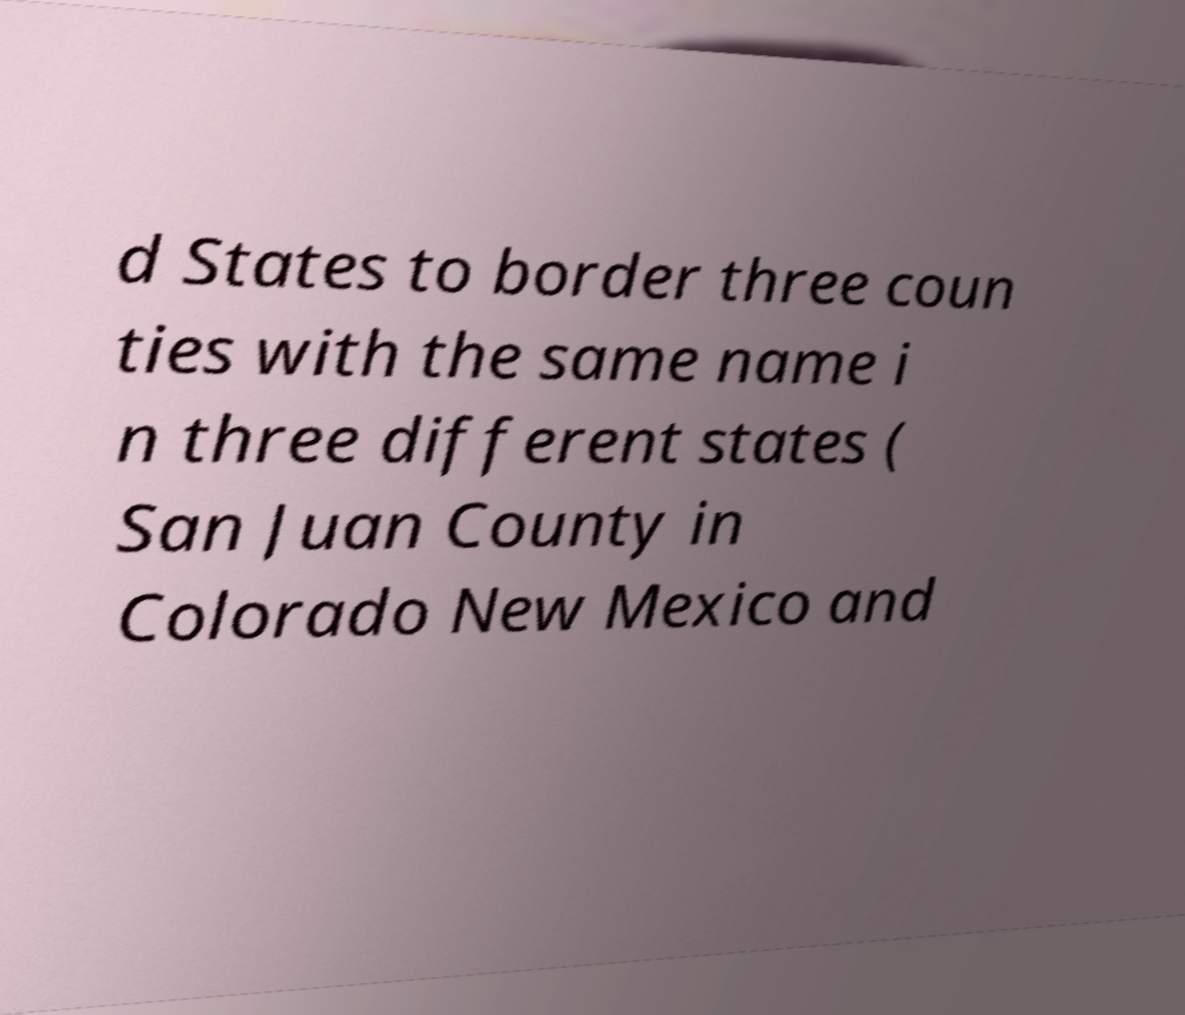Can you accurately transcribe the text from the provided image for me? d States to border three coun ties with the same name i n three different states ( San Juan County in Colorado New Mexico and 